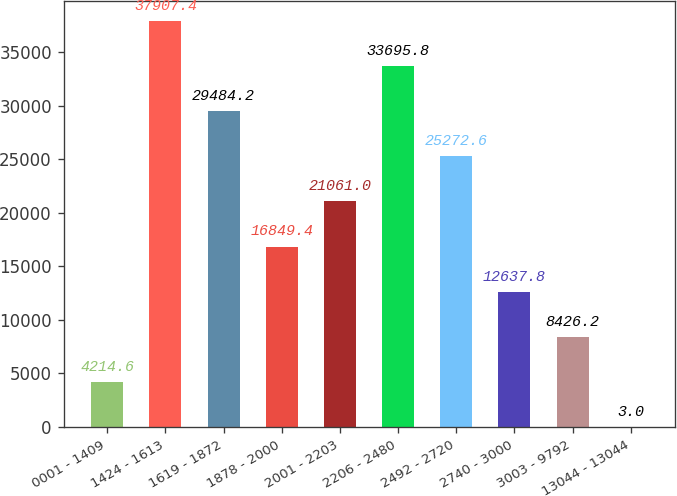Convert chart. <chart><loc_0><loc_0><loc_500><loc_500><bar_chart><fcel>0001 - 1409<fcel>1424 - 1613<fcel>1619 - 1872<fcel>1878 - 2000<fcel>2001 - 2203<fcel>2206 - 2480<fcel>2492 - 2720<fcel>2740 - 3000<fcel>3003 - 9792<fcel>13044 - 13044<nl><fcel>4214.6<fcel>37907.4<fcel>29484.2<fcel>16849.4<fcel>21061<fcel>33695.8<fcel>25272.6<fcel>12637.8<fcel>8426.2<fcel>3<nl></chart> 